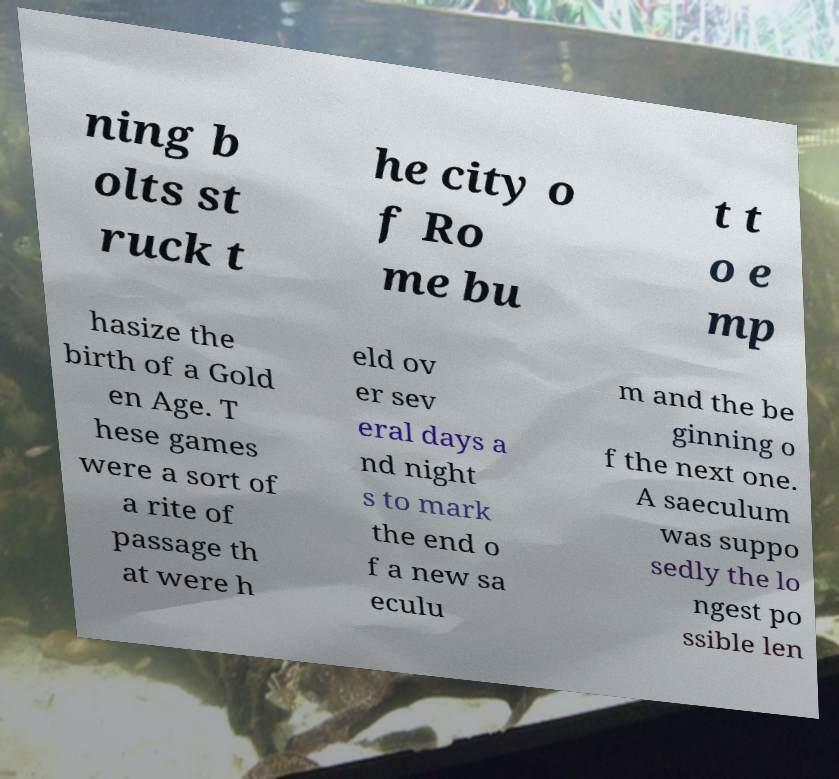Could you assist in decoding the text presented in this image and type it out clearly? ning b olts st ruck t he city o f Ro me bu t t o e mp hasize the birth of a Gold en Age. T hese games were a sort of a rite of passage th at were h eld ov er sev eral days a nd night s to mark the end o f a new sa eculu m and the be ginning o f the next one. A saeculum was suppo sedly the lo ngest po ssible len 